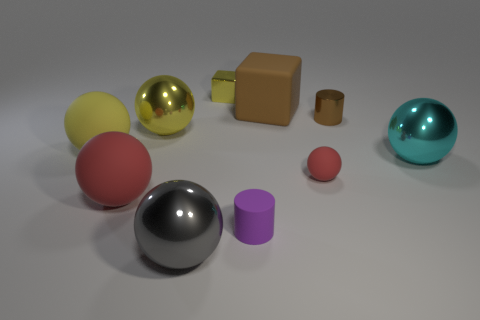Subtract all red rubber spheres. How many spheres are left? 4 Subtract 3 spheres. How many spheres are left? 3 Subtract all red balls. How many balls are left? 4 Subtract all purple spheres. Subtract all red cylinders. How many spheres are left? 6 Subtract all balls. How many objects are left? 4 Add 7 red rubber balls. How many red rubber balls exist? 9 Subtract 1 yellow balls. How many objects are left? 9 Subtract all gray balls. Subtract all big brown cylinders. How many objects are left? 9 Add 1 gray balls. How many gray balls are left? 2 